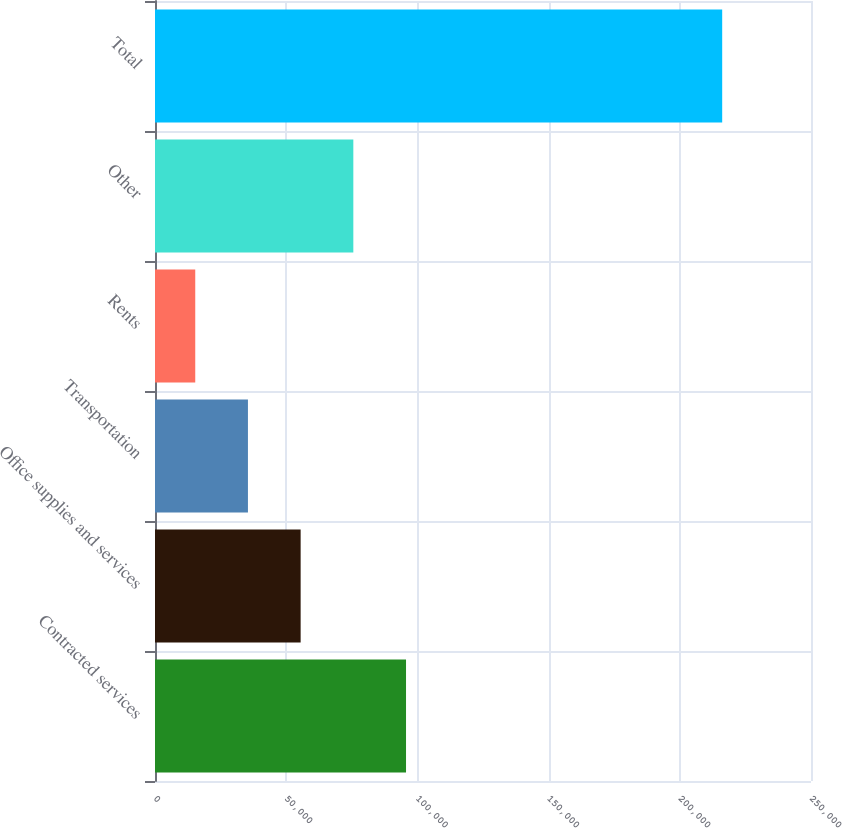Convert chart. <chart><loc_0><loc_0><loc_500><loc_500><bar_chart><fcel>Contracted services<fcel>Office supplies and services<fcel>Transportation<fcel>Rents<fcel>Other<fcel>Total<nl><fcel>95665<fcel>55502<fcel>35420.5<fcel>15339<fcel>75583.5<fcel>216154<nl></chart> 